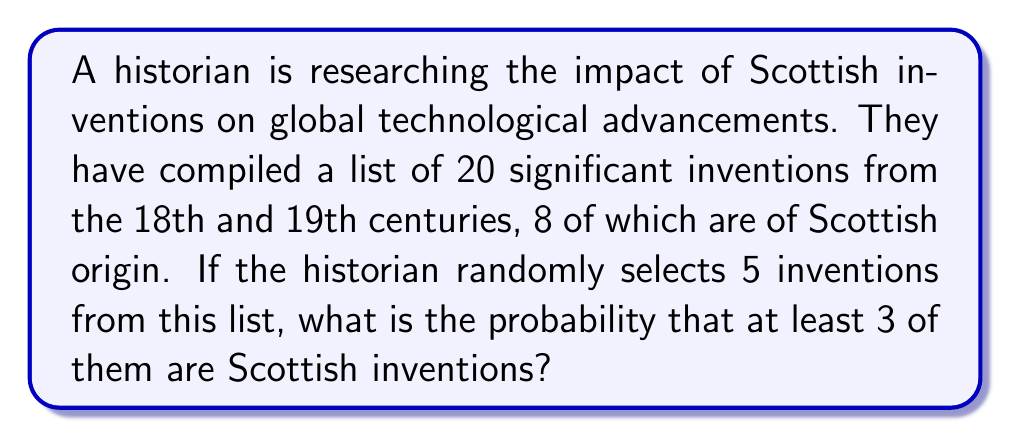Teach me how to tackle this problem. Let's approach this step-by-step using the concept of hypergeometric distribution:

1) We have a total of 20 inventions (N = 20)
2) 8 of these are Scottish inventions (K = 8)
3) We are selecting 5 inventions (n = 5)
4) We want the probability of selecting at least 3 Scottish inventions

We need to calculate:
P(X ≥ 3), where X is the number of Scottish inventions selected

We can calculate this as:
P(X ≥ 3) = P(X = 3) + P(X = 4) + P(X = 5)

Using the hypergeometric distribution formula:

$$P(X = k) = \frac{\binom{K}{k} \binom{N-K}{n-k}}{\binom{N}{n}}$$

Let's calculate each probability:

P(X = 3):
$$P(X = 3) = \frac{\binom{8}{3} \binom{12}{2}}{\binom{20}{5}} = \frac{56 \cdot 66}{15504} = \frac{3696}{15504}$$

P(X = 4):
$$P(X = 4) = \frac{\binom{8}{4} \binom{12}{1}}{\binom{20}{5}} = \frac{70 \cdot 12}{15504} = \frac{840}{15504}$$

P(X = 5):
$$P(X = 5) = \frac{\binom{8}{5} \binom{12}{0}}{\binom{20}{5}} = \frac{56 \cdot 1}{15504} = \frac{56}{15504}$$

Now, we sum these probabilities:

$$P(X ≥ 3) = \frac{3696}{15504} + \frac{840}{15504} + \frac{56}{15504} = \frac{4592}{15504} = \frac{287}{969} \approx 0.2962$$
Answer: $\frac{287}{969}$ or approximately 0.2962 